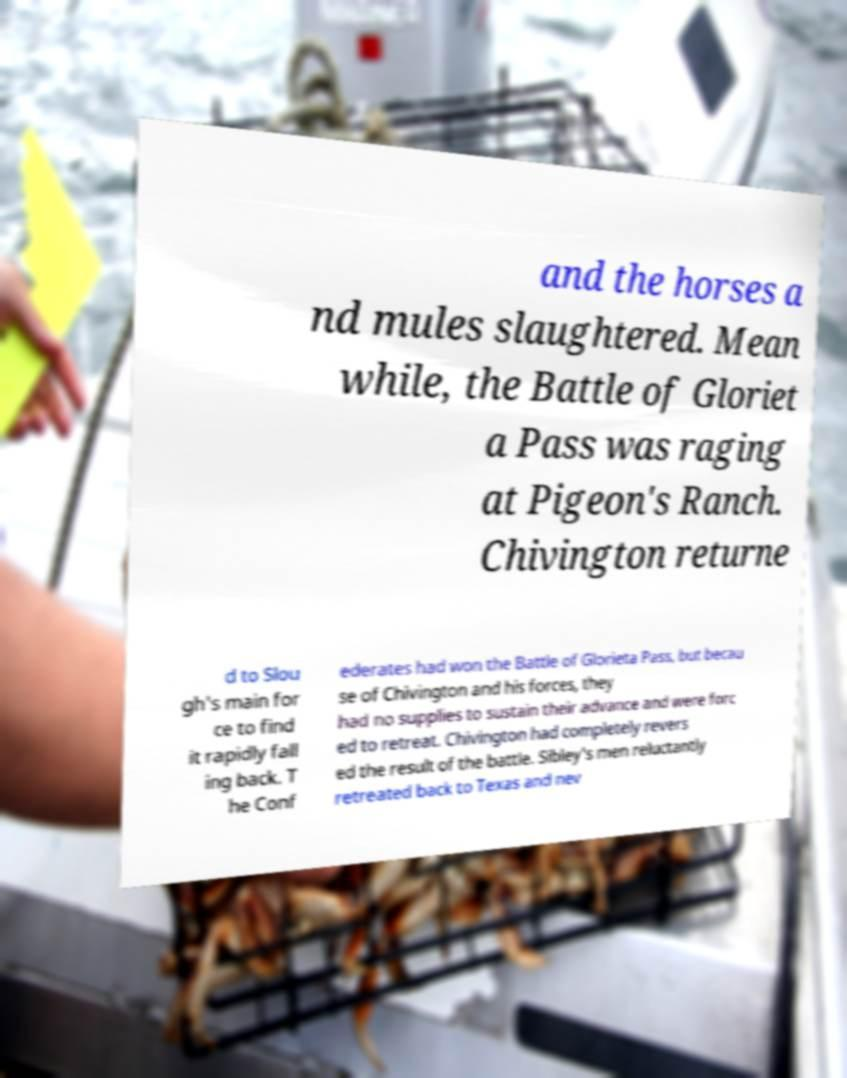Could you extract and type out the text from this image? and the horses a nd mules slaughtered. Mean while, the Battle of Gloriet a Pass was raging at Pigeon's Ranch. Chivington returne d to Slou gh's main for ce to find it rapidly fall ing back. T he Conf ederates had won the Battle of Glorieta Pass, but becau se of Chivington and his forces, they had no supplies to sustain their advance and were forc ed to retreat. Chivington had completely revers ed the result of the battle. Sibley's men reluctantly retreated back to Texas and nev 